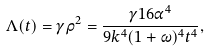<formula> <loc_0><loc_0><loc_500><loc_500>\Lambda ( t ) = \gamma \rho ^ { 2 } = \frac { \gamma { 1 6 \alpha ^ { 4 } } } { 9 k ^ { 4 } ( 1 + \omega ) ^ { 4 } t ^ { 4 } } ,</formula> 